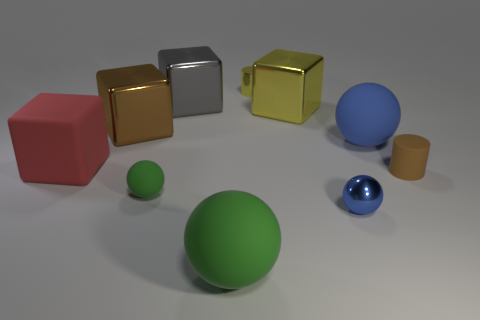How many small objects are either brown metal things or gray metal objects?
Your answer should be compact. 0. There is a metallic thing that is in front of the tiny green matte thing; does it have the same color as the small sphere that is on the left side of the yellow metallic cube?
Provide a short and direct response. No. How many other objects are there of the same color as the metallic cylinder?
Your response must be concise. 1. How many blue objects are tiny metallic spheres or cubes?
Offer a very short reply. 1. There is a large green object; does it have the same shape as the brown object that is on the left side of the small matte sphere?
Offer a very short reply. No. The tiny green rubber object has what shape?
Offer a very short reply. Sphere. What material is the brown object that is the same size as the gray thing?
Keep it short and to the point. Metal. Is there any other thing that has the same size as the brown block?
Provide a short and direct response. Yes. What number of things are either small cyan metallic spheres or tiny shiny balls that are in front of the tiny green object?
Keep it short and to the point. 1. What is the size of the blue thing that is the same material as the yellow block?
Offer a very short reply. Small. 